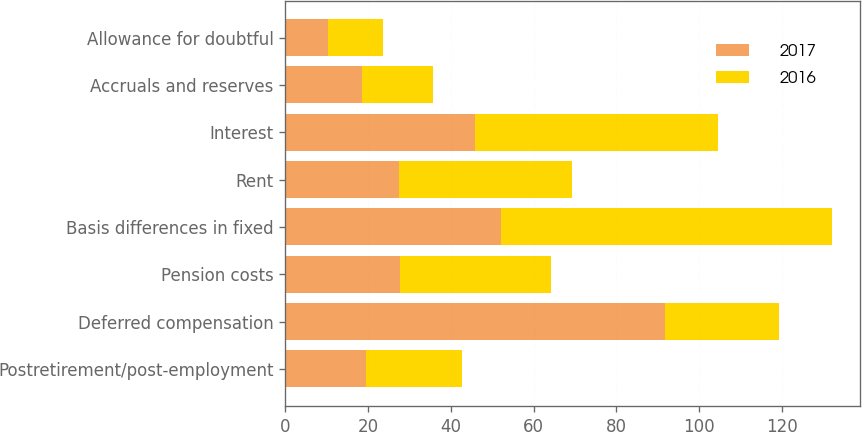Convert chart to OTSL. <chart><loc_0><loc_0><loc_500><loc_500><stacked_bar_chart><ecel><fcel>Postretirement/post-employment<fcel>Deferred compensation<fcel>Pension costs<fcel>Basis differences in fixed<fcel>Rent<fcel>Interest<fcel>Accruals and reserves<fcel>Allowance for doubtful<nl><fcel>2017<fcel>19.5<fcel>91.7<fcel>27.6<fcel>52<fcel>27.5<fcel>45.8<fcel>18.4<fcel>10.2<nl><fcel>2016<fcel>23.1<fcel>27.6<fcel>36.6<fcel>80.2<fcel>41.7<fcel>58.9<fcel>17.2<fcel>13.3<nl></chart> 